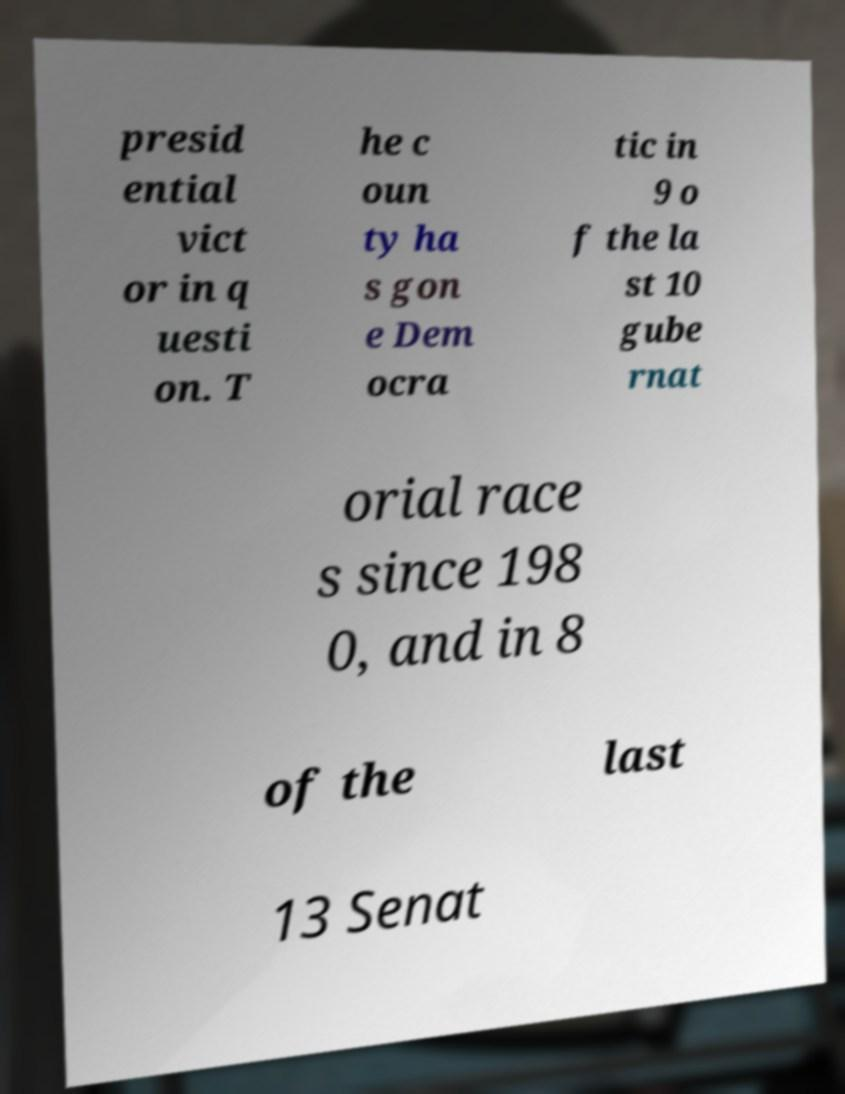Could you extract and type out the text from this image? presid ential vict or in q uesti on. T he c oun ty ha s gon e Dem ocra tic in 9 o f the la st 10 gube rnat orial race s since 198 0, and in 8 of the last 13 Senat 